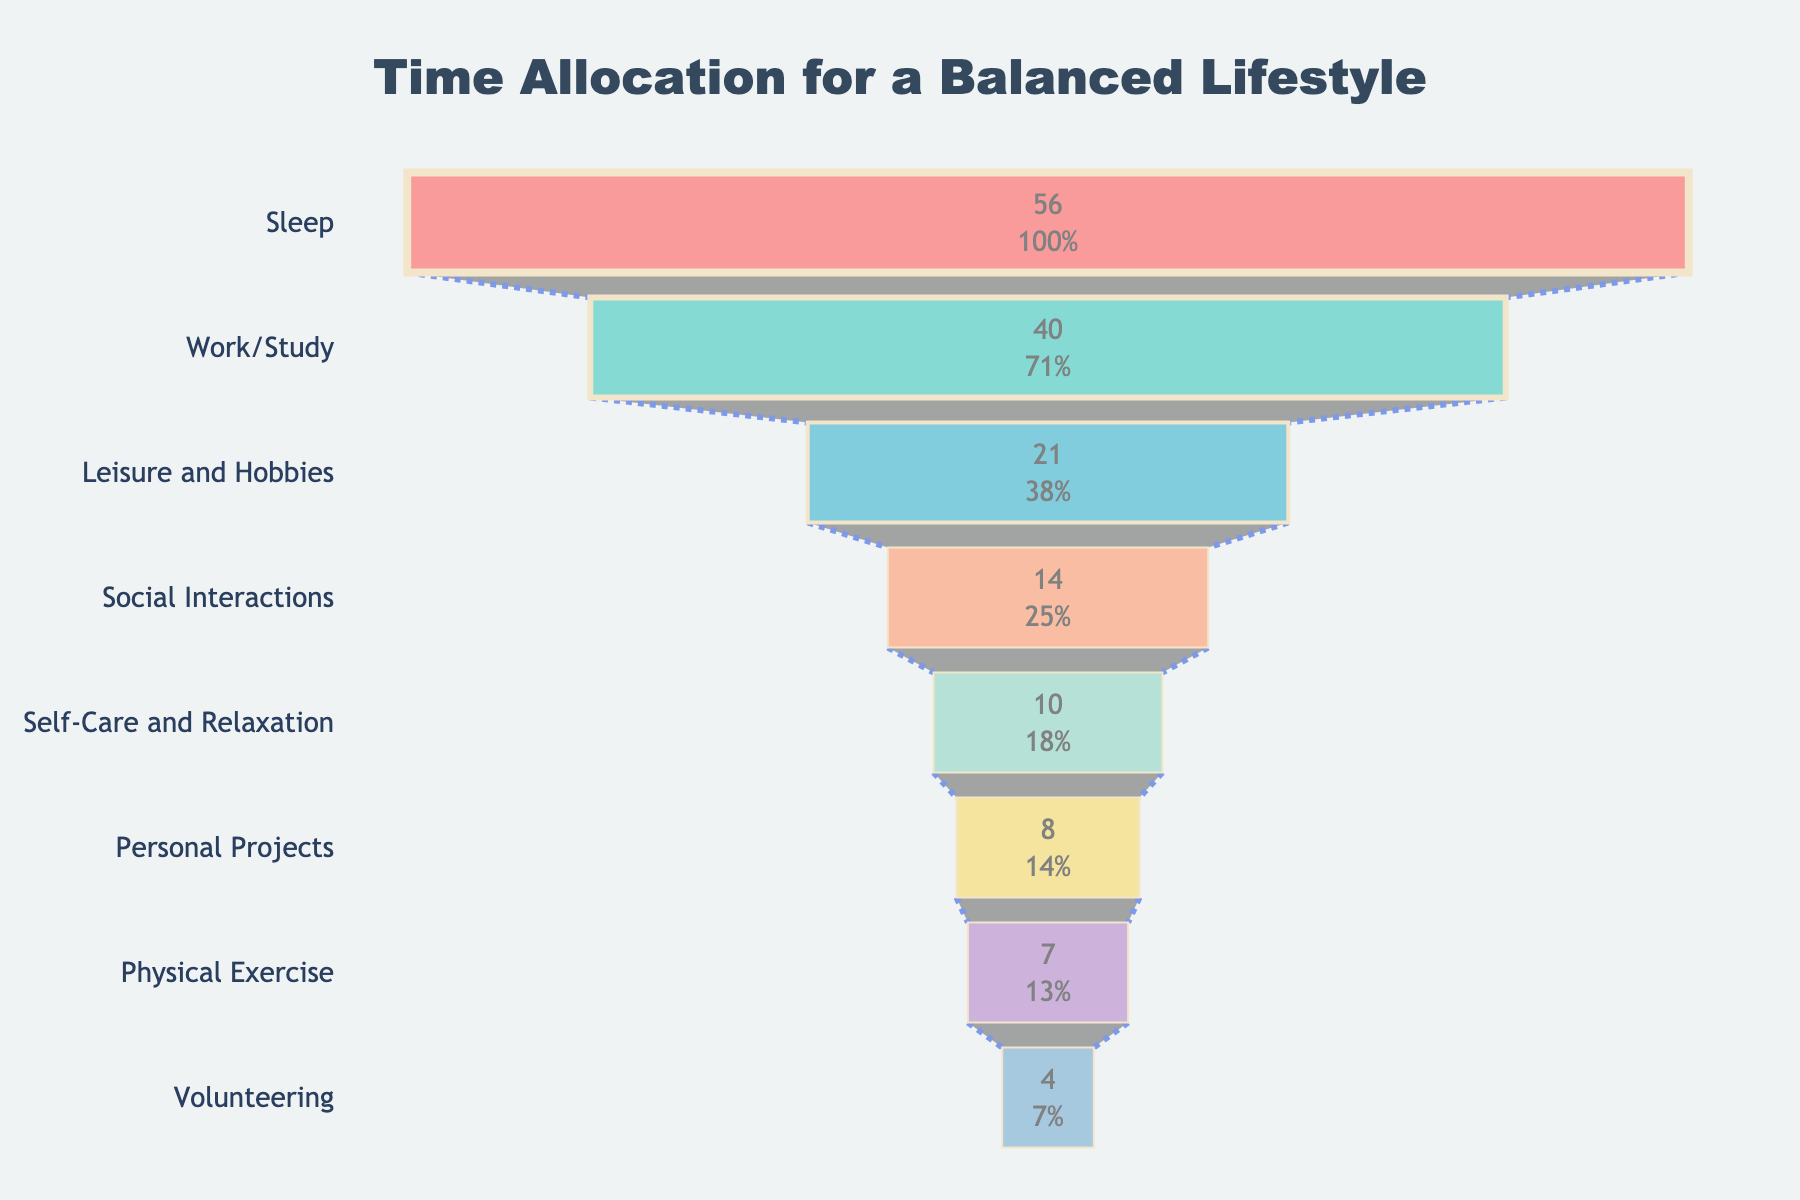what is the title of the figure? The title is generally located at the top of the figure and is used to summarize what the chart is about. The title reads "Time Allocation for a Balanced Lifestyle".
Answer: "Time Allocation for a Balanced Lifestyle" what activity takes the most time per week? The activity at the top of the funnel takes the most time per week, which is "Sleep" with 56 hours.
Answer: Sleep how many hours per week are dedicated to physical exercise? Look for "Physical Exercise" on the chart, which indicates 7 hours per week.
Answer: 7 what color represents leisure and hobbies? Leisure and Hobbies is the third activity on the list and has a distinctive bluish color (#45B7D1).
Answer: Bluish How many more hours are dedicated to Social Interactions compared to Volunteering? Social Interactions are 14 hours per week and Volunteering is 4 hours per week. The difference is 14 - 4 = 10 hours.
Answer: 10 hours which activity has fewer weekly hours: Personal Projects or Self-Care and Relaxation? Personal Projects have 8 hours per week, while Self-Care and Relaxation has 10 hours. So, Personal Projects have fewer hours.
Answer: Personal Projects is the time spent on Work/Study higher than the time spent on Social Interactions plus Physical Exercise? Work/Study is 40 hours. Social Interactions (14) + Physical Exercise (7) = 21 hours. 40 is greater than 21.
Answer: Yes what is the combined time spent per week on Leisure and Hobbies, Social Interactions, and Personal Projects? Adding the time across these three activities: 21 + 14 + 8 = 43 hours per week.
Answer: 43 hours what is the smallest number of hours per week dedicated to an activity? Volunteering has the smallest number of hours per week, which is 4 hours.
Answer: 4 what percentage of the total weekly hours does Sleep occupy? Total weekly hours can be calculated by adding hours for all activities: 56 + 40 + 21 + 14 + 7 + 10 + 8 + 4 = 160. Sleep is 56 hours. The percentage is (56 / 160) * 100 = 35%.
Answer: 35% 